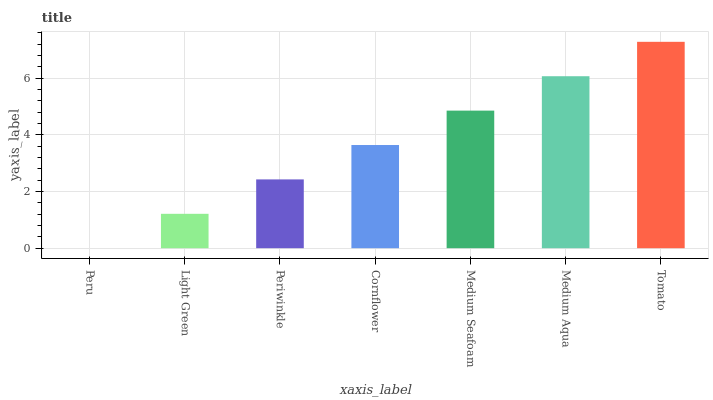Is Peru the minimum?
Answer yes or no. Yes. Is Tomato the maximum?
Answer yes or no. Yes. Is Light Green the minimum?
Answer yes or no. No. Is Light Green the maximum?
Answer yes or no. No. Is Light Green greater than Peru?
Answer yes or no. Yes. Is Peru less than Light Green?
Answer yes or no. Yes. Is Peru greater than Light Green?
Answer yes or no. No. Is Light Green less than Peru?
Answer yes or no. No. Is Cornflower the high median?
Answer yes or no. Yes. Is Cornflower the low median?
Answer yes or no. Yes. Is Medium Seafoam the high median?
Answer yes or no. No. Is Tomato the low median?
Answer yes or no. No. 